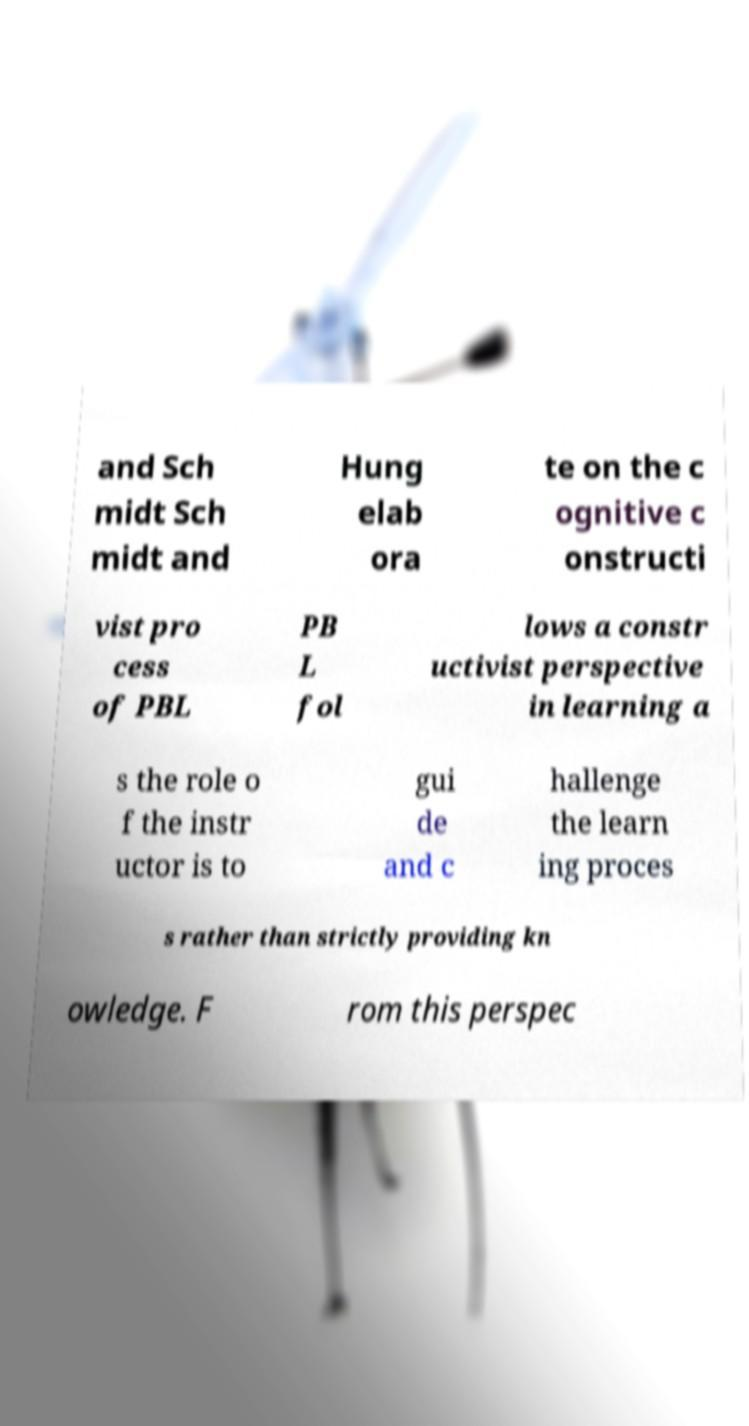Please read and relay the text visible in this image. What does it say? and Sch midt Sch midt and Hung elab ora te on the c ognitive c onstructi vist pro cess of PBL PB L fol lows a constr uctivist perspective in learning a s the role o f the instr uctor is to gui de and c hallenge the learn ing proces s rather than strictly providing kn owledge. F rom this perspec 